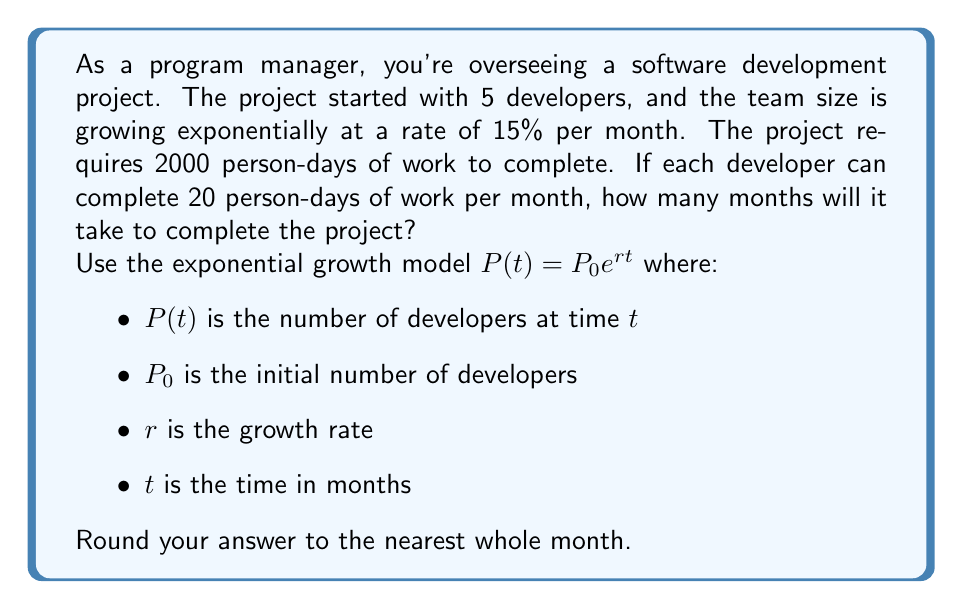Show me your answer to this math problem. Let's approach this step-by-step:

1) First, we need to set up our exponential growth model:
   $P(t) = 5e^{0.15t}$

2) Now, we need to find the total person-days completed after $t$ months. This is the integral of $P(t)$ multiplied by 20 (since each developer completes 20 person-days per month):

   $\int_0^t 20P(t) dt = \int_0^t 100e^{0.15t} dt$

3) Solving this integral:
   $[\frac{100}{0.15}e^{0.15t}]_0^t = \frac{100}{0.15}(e^{0.15t} - 1)$

4) We want this to equal 2000 person-days:
   $\frac{100}{0.15}(e^{0.15t} - 1) = 2000$

5) Solving for $t$:
   $e^{0.15t} - 1 = 2000 \cdot \frac{0.15}{100} = 3$
   $e^{0.15t} = 4$
   $0.15t = \ln(4)$
   $t = \frac{\ln(4)}{0.15} \approx 9.2$ months

6) Rounding to the nearest whole month, we get 9 months.
Answer: 9 months 